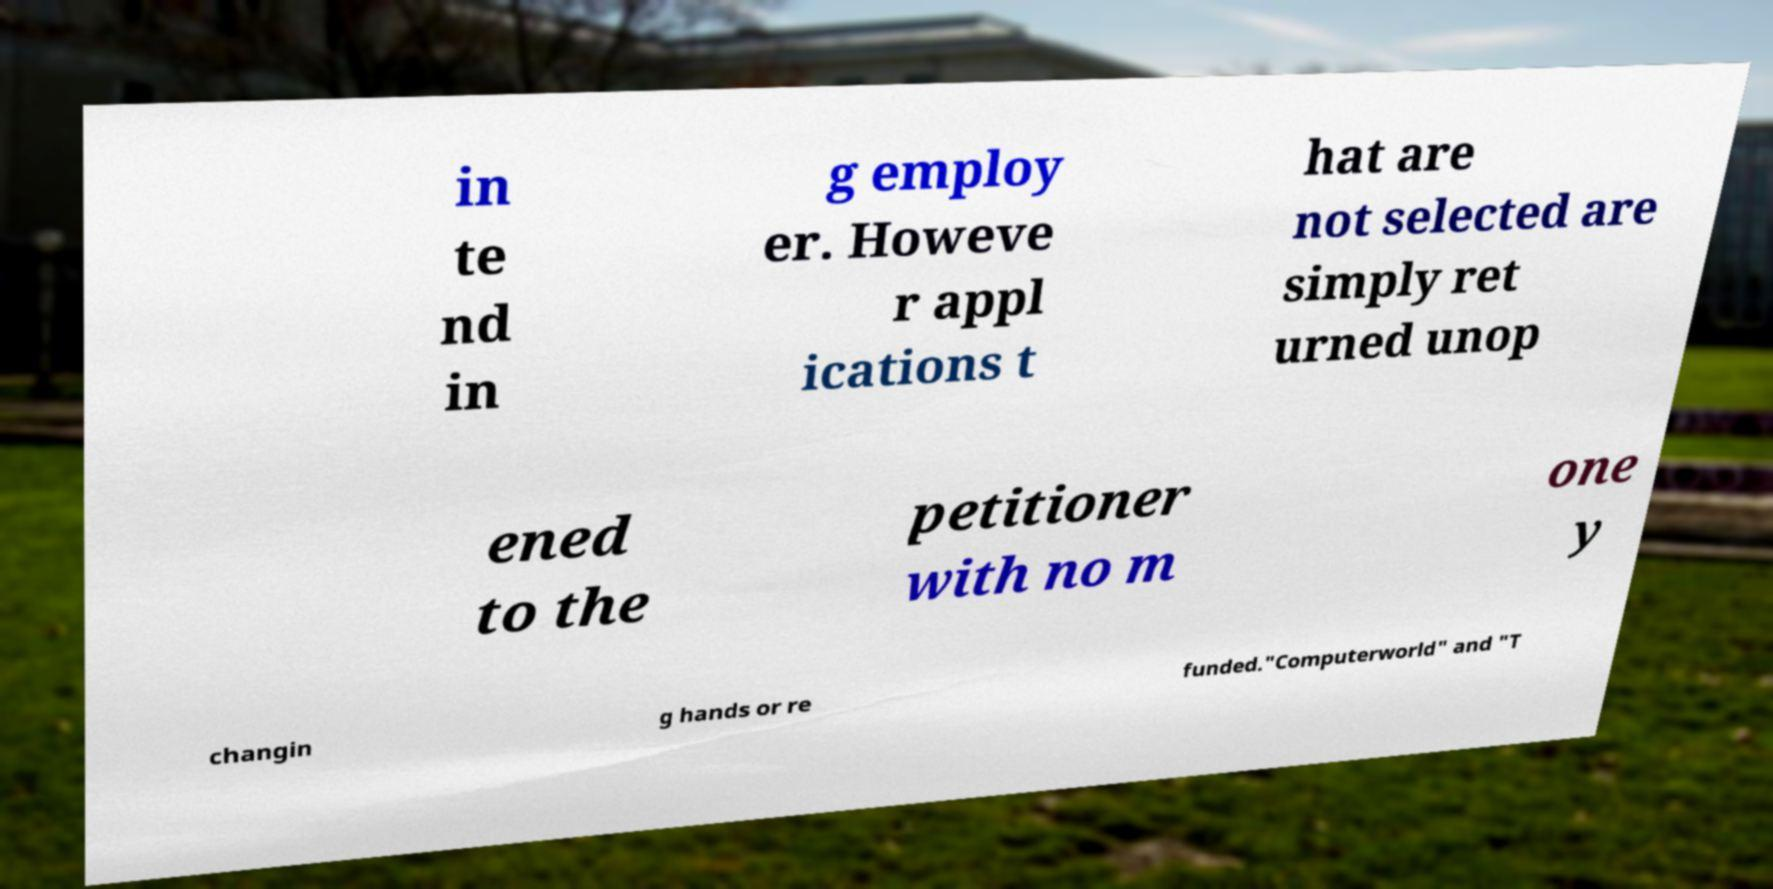What messages or text are displayed in this image? I need them in a readable, typed format. in te nd in g employ er. Howeve r appl ications t hat are not selected are simply ret urned unop ened to the petitioner with no m one y changin g hands or re funded."Computerworld" and "T 